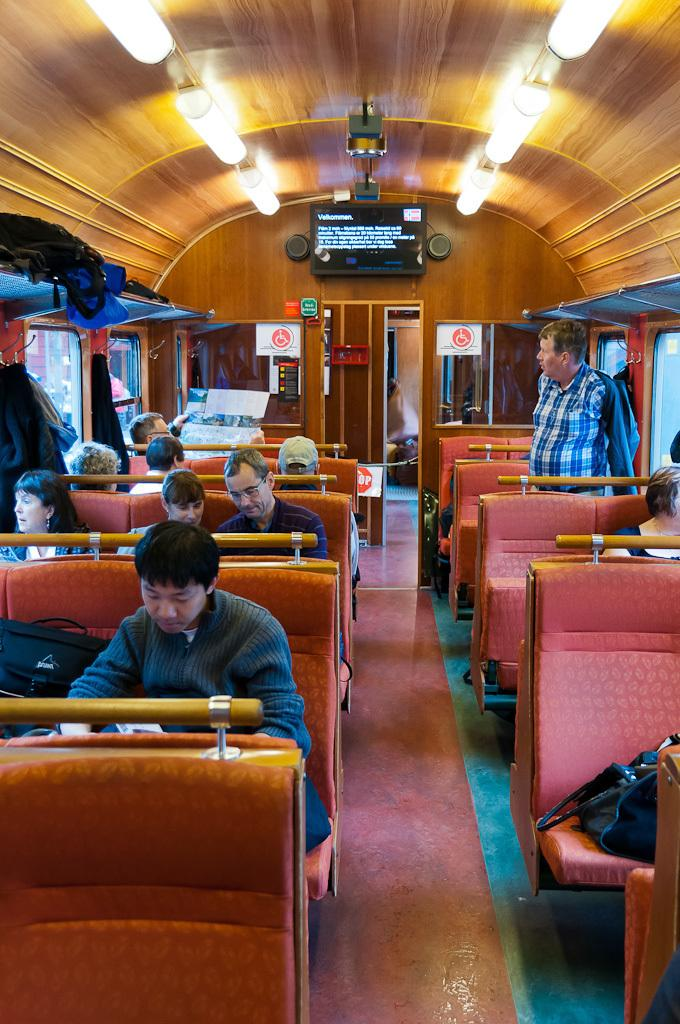What type of vehicle is the image taken inside? The image is inside a train. What are the passengers doing in the image? Passengers are sitting in the seats, and at least one passenger is standing. What can be seen in the background of the image? There is a television in the background. What safety feature is present in the image? A fire extinguisher is present. What can be used to provide illumination in the image? There are lights visible in the image. Where is the mom taking a bath in the image? There is no mom or bath present in the image. What type of slip is visible on the floor in the image? There is no slip visible on the floor in the image. 